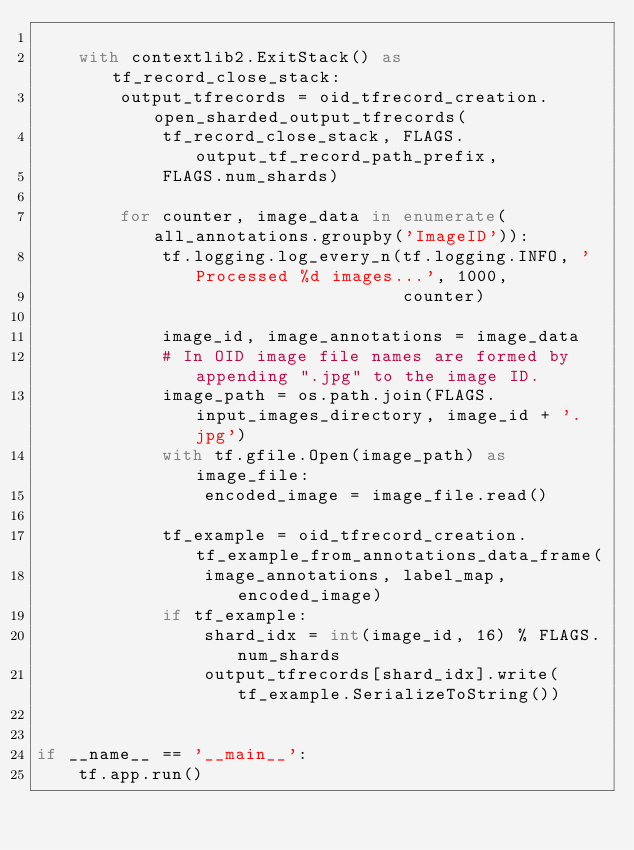<code> <loc_0><loc_0><loc_500><loc_500><_Python_>
    with contextlib2.ExitStack() as tf_record_close_stack:
        output_tfrecords = oid_tfrecord_creation.open_sharded_output_tfrecords(
            tf_record_close_stack, FLAGS.output_tf_record_path_prefix,
            FLAGS.num_shards)

        for counter, image_data in enumerate(all_annotations.groupby('ImageID')):
            tf.logging.log_every_n(tf.logging.INFO, 'Processed %d images...', 1000,
                                   counter)

            image_id, image_annotations = image_data
            # In OID image file names are formed by appending ".jpg" to the image ID.
            image_path = os.path.join(FLAGS.input_images_directory, image_id + '.jpg')
            with tf.gfile.Open(image_path) as image_file:
                encoded_image = image_file.read()

            tf_example = oid_tfrecord_creation.tf_example_from_annotations_data_frame(
                image_annotations, label_map, encoded_image)
            if tf_example:
                shard_idx = int(image_id, 16) % FLAGS.num_shards
                output_tfrecords[shard_idx].write(tf_example.SerializeToString())


if __name__ == '__main__':
    tf.app.run()
</code> 